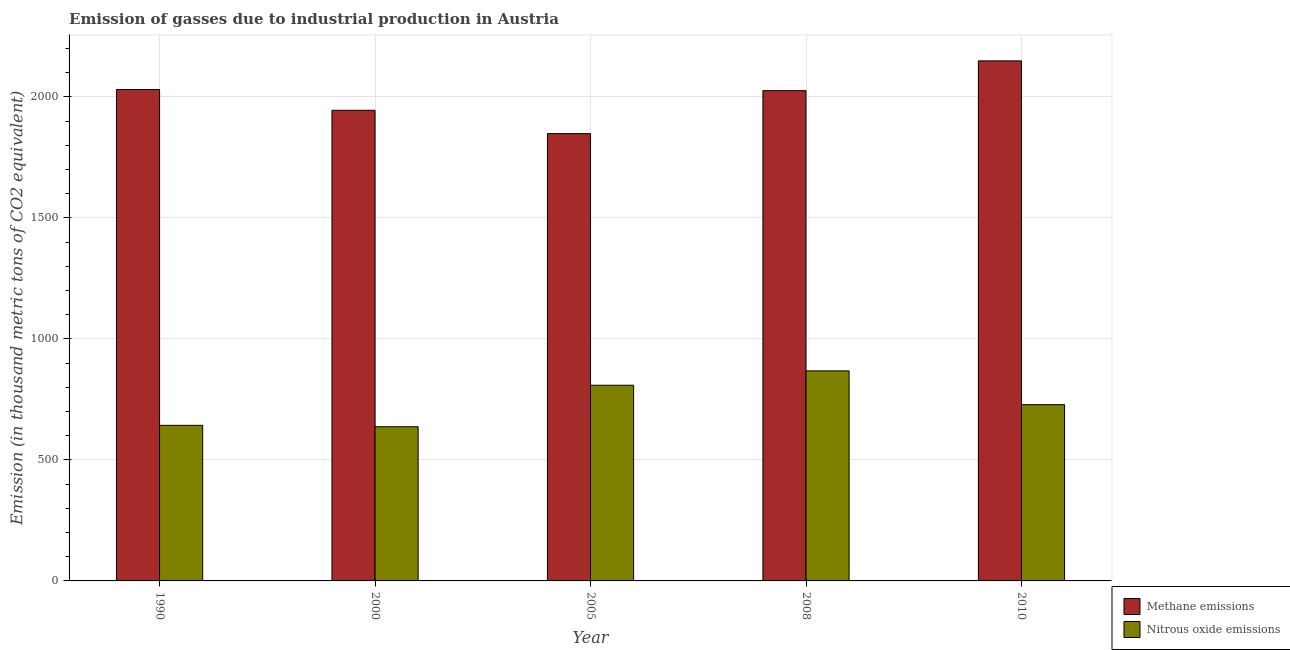Are the number of bars per tick equal to the number of legend labels?
Offer a terse response. Yes. How many bars are there on the 4th tick from the left?
Your response must be concise. 2. What is the amount of methane emissions in 2000?
Your answer should be compact. 1944.7. Across all years, what is the maximum amount of methane emissions?
Provide a short and direct response. 2148.9. Across all years, what is the minimum amount of nitrous oxide emissions?
Keep it short and to the point. 637.1. What is the total amount of nitrous oxide emissions in the graph?
Your answer should be very brief. 3684.8. What is the difference between the amount of methane emissions in 1990 and that in 2010?
Provide a succinct answer. -118.3. What is the difference between the amount of nitrous oxide emissions in 1990 and the amount of methane emissions in 2010?
Offer a very short reply. -85.4. What is the average amount of methane emissions per year?
Ensure brevity in your answer.  1999.66. In how many years, is the amount of methane emissions greater than 400 thousand metric tons?
Give a very brief answer. 5. What is the ratio of the amount of nitrous oxide emissions in 2000 to that in 2010?
Provide a succinct answer. 0.87. Is the amount of methane emissions in 1990 less than that in 2010?
Your answer should be compact. Yes. What is the difference between the highest and the second highest amount of methane emissions?
Offer a very short reply. 118.3. What is the difference between the highest and the lowest amount of nitrous oxide emissions?
Provide a succinct answer. 230.8. In how many years, is the amount of nitrous oxide emissions greater than the average amount of nitrous oxide emissions taken over all years?
Your response must be concise. 2. What does the 2nd bar from the left in 2010 represents?
Offer a very short reply. Nitrous oxide emissions. What does the 2nd bar from the right in 2010 represents?
Provide a short and direct response. Methane emissions. Are all the bars in the graph horizontal?
Your answer should be very brief. No. How many years are there in the graph?
Offer a very short reply. 5. How many legend labels are there?
Your response must be concise. 2. How are the legend labels stacked?
Provide a short and direct response. Vertical. What is the title of the graph?
Provide a short and direct response. Emission of gasses due to industrial production in Austria. What is the label or title of the Y-axis?
Make the answer very short. Emission (in thousand metric tons of CO2 equivalent). What is the Emission (in thousand metric tons of CO2 equivalent) in Methane emissions in 1990?
Give a very brief answer. 2030.6. What is the Emission (in thousand metric tons of CO2 equivalent) in Nitrous oxide emissions in 1990?
Your response must be concise. 642.9. What is the Emission (in thousand metric tons of CO2 equivalent) of Methane emissions in 2000?
Your answer should be compact. 1944.7. What is the Emission (in thousand metric tons of CO2 equivalent) in Nitrous oxide emissions in 2000?
Give a very brief answer. 637.1. What is the Emission (in thousand metric tons of CO2 equivalent) of Methane emissions in 2005?
Keep it short and to the point. 1848.3. What is the Emission (in thousand metric tons of CO2 equivalent) in Nitrous oxide emissions in 2005?
Your answer should be very brief. 808.6. What is the Emission (in thousand metric tons of CO2 equivalent) of Methane emissions in 2008?
Your response must be concise. 2025.8. What is the Emission (in thousand metric tons of CO2 equivalent) of Nitrous oxide emissions in 2008?
Offer a very short reply. 867.9. What is the Emission (in thousand metric tons of CO2 equivalent) in Methane emissions in 2010?
Offer a terse response. 2148.9. What is the Emission (in thousand metric tons of CO2 equivalent) in Nitrous oxide emissions in 2010?
Your response must be concise. 728.3. Across all years, what is the maximum Emission (in thousand metric tons of CO2 equivalent) in Methane emissions?
Provide a short and direct response. 2148.9. Across all years, what is the maximum Emission (in thousand metric tons of CO2 equivalent) in Nitrous oxide emissions?
Your answer should be very brief. 867.9. Across all years, what is the minimum Emission (in thousand metric tons of CO2 equivalent) in Methane emissions?
Ensure brevity in your answer.  1848.3. Across all years, what is the minimum Emission (in thousand metric tons of CO2 equivalent) of Nitrous oxide emissions?
Give a very brief answer. 637.1. What is the total Emission (in thousand metric tons of CO2 equivalent) of Methane emissions in the graph?
Give a very brief answer. 9998.3. What is the total Emission (in thousand metric tons of CO2 equivalent) of Nitrous oxide emissions in the graph?
Ensure brevity in your answer.  3684.8. What is the difference between the Emission (in thousand metric tons of CO2 equivalent) in Methane emissions in 1990 and that in 2000?
Offer a very short reply. 85.9. What is the difference between the Emission (in thousand metric tons of CO2 equivalent) of Methane emissions in 1990 and that in 2005?
Keep it short and to the point. 182.3. What is the difference between the Emission (in thousand metric tons of CO2 equivalent) of Nitrous oxide emissions in 1990 and that in 2005?
Make the answer very short. -165.7. What is the difference between the Emission (in thousand metric tons of CO2 equivalent) of Nitrous oxide emissions in 1990 and that in 2008?
Ensure brevity in your answer.  -225. What is the difference between the Emission (in thousand metric tons of CO2 equivalent) in Methane emissions in 1990 and that in 2010?
Your response must be concise. -118.3. What is the difference between the Emission (in thousand metric tons of CO2 equivalent) of Nitrous oxide emissions in 1990 and that in 2010?
Ensure brevity in your answer.  -85.4. What is the difference between the Emission (in thousand metric tons of CO2 equivalent) in Methane emissions in 2000 and that in 2005?
Your answer should be compact. 96.4. What is the difference between the Emission (in thousand metric tons of CO2 equivalent) of Nitrous oxide emissions in 2000 and that in 2005?
Give a very brief answer. -171.5. What is the difference between the Emission (in thousand metric tons of CO2 equivalent) of Methane emissions in 2000 and that in 2008?
Offer a very short reply. -81.1. What is the difference between the Emission (in thousand metric tons of CO2 equivalent) in Nitrous oxide emissions in 2000 and that in 2008?
Your response must be concise. -230.8. What is the difference between the Emission (in thousand metric tons of CO2 equivalent) of Methane emissions in 2000 and that in 2010?
Ensure brevity in your answer.  -204.2. What is the difference between the Emission (in thousand metric tons of CO2 equivalent) in Nitrous oxide emissions in 2000 and that in 2010?
Ensure brevity in your answer.  -91.2. What is the difference between the Emission (in thousand metric tons of CO2 equivalent) of Methane emissions in 2005 and that in 2008?
Keep it short and to the point. -177.5. What is the difference between the Emission (in thousand metric tons of CO2 equivalent) of Nitrous oxide emissions in 2005 and that in 2008?
Provide a succinct answer. -59.3. What is the difference between the Emission (in thousand metric tons of CO2 equivalent) in Methane emissions in 2005 and that in 2010?
Keep it short and to the point. -300.6. What is the difference between the Emission (in thousand metric tons of CO2 equivalent) in Nitrous oxide emissions in 2005 and that in 2010?
Provide a succinct answer. 80.3. What is the difference between the Emission (in thousand metric tons of CO2 equivalent) in Methane emissions in 2008 and that in 2010?
Your answer should be compact. -123.1. What is the difference between the Emission (in thousand metric tons of CO2 equivalent) of Nitrous oxide emissions in 2008 and that in 2010?
Your response must be concise. 139.6. What is the difference between the Emission (in thousand metric tons of CO2 equivalent) in Methane emissions in 1990 and the Emission (in thousand metric tons of CO2 equivalent) in Nitrous oxide emissions in 2000?
Make the answer very short. 1393.5. What is the difference between the Emission (in thousand metric tons of CO2 equivalent) of Methane emissions in 1990 and the Emission (in thousand metric tons of CO2 equivalent) of Nitrous oxide emissions in 2005?
Offer a very short reply. 1222. What is the difference between the Emission (in thousand metric tons of CO2 equivalent) of Methane emissions in 1990 and the Emission (in thousand metric tons of CO2 equivalent) of Nitrous oxide emissions in 2008?
Give a very brief answer. 1162.7. What is the difference between the Emission (in thousand metric tons of CO2 equivalent) in Methane emissions in 1990 and the Emission (in thousand metric tons of CO2 equivalent) in Nitrous oxide emissions in 2010?
Ensure brevity in your answer.  1302.3. What is the difference between the Emission (in thousand metric tons of CO2 equivalent) of Methane emissions in 2000 and the Emission (in thousand metric tons of CO2 equivalent) of Nitrous oxide emissions in 2005?
Make the answer very short. 1136.1. What is the difference between the Emission (in thousand metric tons of CO2 equivalent) of Methane emissions in 2000 and the Emission (in thousand metric tons of CO2 equivalent) of Nitrous oxide emissions in 2008?
Make the answer very short. 1076.8. What is the difference between the Emission (in thousand metric tons of CO2 equivalent) in Methane emissions in 2000 and the Emission (in thousand metric tons of CO2 equivalent) in Nitrous oxide emissions in 2010?
Offer a terse response. 1216.4. What is the difference between the Emission (in thousand metric tons of CO2 equivalent) of Methane emissions in 2005 and the Emission (in thousand metric tons of CO2 equivalent) of Nitrous oxide emissions in 2008?
Make the answer very short. 980.4. What is the difference between the Emission (in thousand metric tons of CO2 equivalent) in Methane emissions in 2005 and the Emission (in thousand metric tons of CO2 equivalent) in Nitrous oxide emissions in 2010?
Provide a succinct answer. 1120. What is the difference between the Emission (in thousand metric tons of CO2 equivalent) of Methane emissions in 2008 and the Emission (in thousand metric tons of CO2 equivalent) of Nitrous oxide emissions in 2010?
Offer a terse response. 1297.5. What is the average Emission (in thousand metric tons of CO2 equivalent) in Methane emissions per year?
Your answer should be compact. 1999.66. What is the average Emission (in thousand metric tons of CO2 equivalent) of Nitrous oxide emissions per year?
Make the answer very short. 736.96. In the year 1990, what is the difference between the Emission (in thousand metric tons of CO2 equivalent) in Methane emissions and Emission (in thousand metric tons of CO2 equivalent) in Nitrous oxide emissions?
Provide a short and direct response. 1387.7. In the year 2000, what is the difference between the Emission (in thousand metric tons of CO2 equivalent) in Methane emissions and Emission (in thousand metric tons of CO2 equivalent) in Nitrous oxide emissions?
Your answer should be compact. 1307.6. In the year 2005, what is the difference between the Emission (in thousand metric tons of CO2 equivalent) of Methane emissions and Emission (in thousand metric tons of CO2 equivalent) of Nitrous oxide emissions?
Offer a very short reply. 1039.7. In the year 2008, what is the difference between the Emission (in thousand metric tons of CO2 equivalent) of Methane emissions and Emission (in thousand metric tons of CO2 equivalent) of Nitrous oxide emissions?
Offer a terse response. 1157.9. In the year 2010, what is the difference between the Emission (in thousand metric tons of CO2 equivalent) of Methane emissions and Emission (in thousand metric tons of CO2 equivalent) of Nitrous oxide emissions?
Your answer should be very brief. 1420.6. What is the ratio of the Emission (in thousand metric tons of CO2 equivalent) of Methane emissions in 1990 to that in 2000?
Your answer should be very brief. 1.04. What is the ratio of the Emission (in thousand metric tons of CO2 equivalent) in Nitrous oxide emissions in 1990 to that in 2000?
Your answer should be compact. 1.01. What is the ratio of the Emission (in thousand metric tons of CO2 equivalent) in Methane emissions in 1990 to that in 2005?
Your response must be concise. 1.1. What is the ratio of the Emission (in thousand metric tons of CO2 equivalent) of Nitrous oxide emissions in 1990 to that in 2005?
Offer a terse response. 0.8. What is the ratio of the Emission (in thousand metric tons of CO2 equivalent) in Nitrous oxide emissions in 1990 to that in 2008?
Offer a terse response. 0.74. What is the ratio of the Emission (in thousand metric tons of CO2 equivalent) in Methane emissions in 1990 to that in 2010?
Offer a terse response. 0.94. What is the ratio of the Emission (in thousand metric tons of CO2 equivalent) in Nitrous oxide emissions in 1990 to that in 2010?
Provide a short and direct response. 0.88. What is the ratio of the Emission (in thousand metric tons of CO2 equivalent) of Methane emissions in 2000 to that in 2005?
Your response must be concise. 1.05. What is the ratio of the Emission (in thousand metric tons of CO2 equivalent) of Nitrous oxide emissions in 2000 to that in 2005?
Ensure brevity in your answer.  0.79. What is the ratio of the Emission (in thousand metric tons of CO2 equivalent) of Nitrous oxide emissions in 2000 to that in 2008?
Provide a short and direct response. 0.73. What is the ratio of the Emission (in thousand metric tons of CO2 equivalent) of Methane emissions in 2000 to that in 2010?
Your response must be concise. 0.91. What is the ratio of the Emission (in thousand metric tons of CO2 equivalent) of Nitrous oxide emissions in 2000 to that in 2010?
Your response must be concise. 0.87. What is the ratio of the Emission (in thousand metric tons of CO2 equivalent) of Methane emissions in 2005 to that in 2008?
Ensure brevity in your answer.  0.91. What is the ratio of the Emission (in thousand metric tons of CO2 equivalent) in Nitrous oxide emissions in 2005 to that in 2008?
Offer a very short reply. 0.93. What is the ratio of the Emission (in thousand metric tons of CO2 equivalent) in Methane emissions in 2005 to that in 2010?
Provide a short and direct response. 0.86. What is the ratio of the Emission (in thousand metric tons of CO2 equivalent) of Nitrous oxide emissions in 2005 to that in 2010?
Offer a very short reply. 1.11. What is the ratio of the Emission (in thousand metric tons of CO2 equivalent) in Methane emissions in 2008 to that in 2010?
Provide a succinct answer. 0.94. What is the ratio of the Emission (in thousand metric tons of CO2 equivalent) in Nitrous oxide emissions in 2008 to that in 2010?
Offer a very short reply. 1.19. What is the difference between the highest and the second highest Emission (in thousand metric tons of CO2 equivalent) of Methane emissions?
Your answer should be compact. 118.3. What is the difference between the highest and the second highest Emission (in thousand metric tons of CO2 equivalent) in Nitrous oxide emissions?
Your response must be concise. 59.3. What is the difference between the highest and the lowest Emission (in thousand metric tons of CO2 equivalent) in Methane emissions?
Offer a terse response. 300.6. What is the difference between the highest and the lowest Emission (in thousand metric tons of CO2 equivalent) in Nitrous oxide emissions?
Keep it short and to the point. 230.8. 